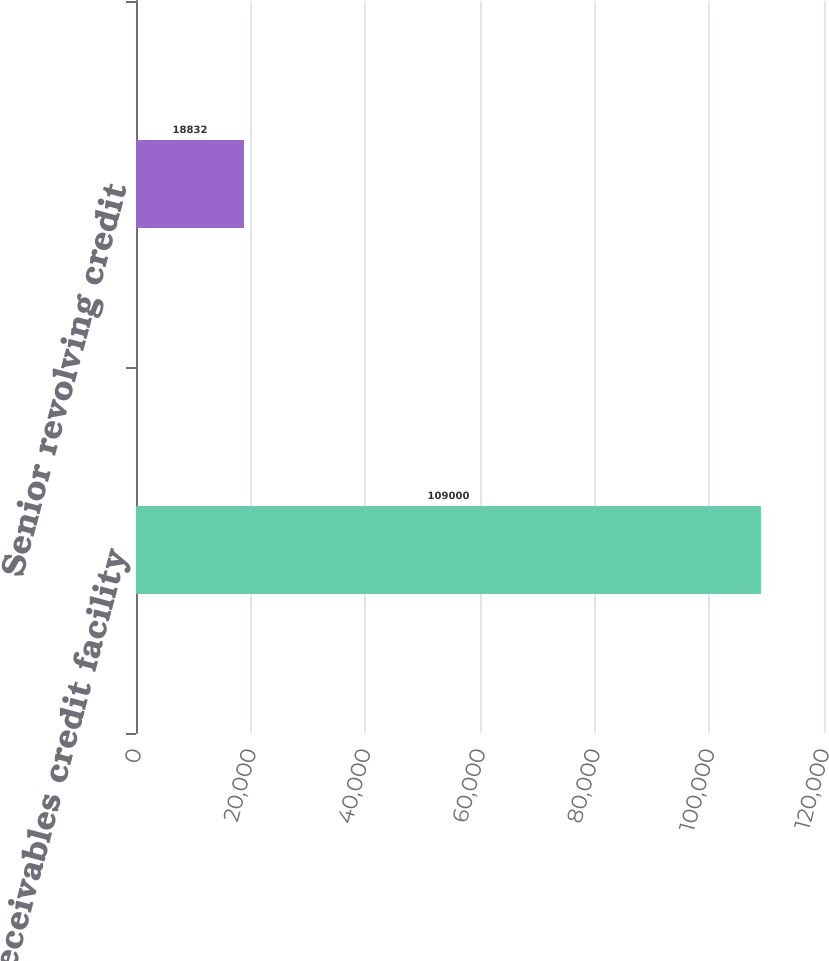<chart> <loc_0><loc_0><loc_500><loc_500><bar_chart><fcel>Receivables credit facility<fcel>Senior revolving credit<nl><fcel>109000<fcel>18832<nl></chart> 